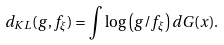<formula> <loc_0><loc_0><loc_500><loc_500>d _ { K L } ( g , f _ { \xi } ) = \int \log \left ( g / f _ { \xi } \right ) d G ( x ) .</formula> 